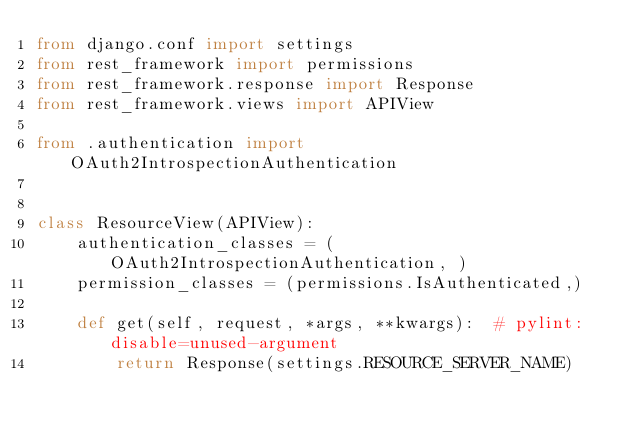<code> <loc_0><loc_0><loc_500><loc_500><_Python_>from django.conf import settings
from rest_framework import permissions
from rest_framework.response import Response
from rest_framework.views import APIView

from .authentication import OAuth2IntrospectionAuthentication


class ResourceView(APIView):
    authentication_classes = (OAuth2IntrospectionAuthentication, )
    permission_classes = (permissions.IsAuthenticated,)

    def get(self, request, *args, **kwargs):  # pylint: disable=unused-argument
        return Response(settings.RESOURCE_SERVER_NAME)
</code> 